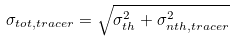<formula> <loc_0><loc_0><loc_500><loc_500>\sigma _ { t o t , t r a c e r } = \sqrt { \sigma _ { t h } ^ { 2 } + \sigma _ { n t h , t r a c e r } ^ { 2 } }</formula> 